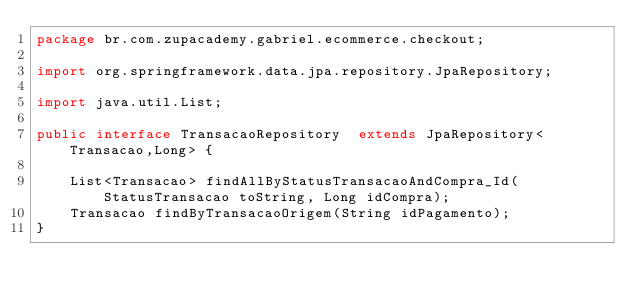<code> <loc_0><loc_0><loc_500><loc_500><_Java_>package br.com.zupacademy.gabriel.ecommerce.checkout;

import org.springframework.data.jpa.repository.JpaRepository;

import java.util.List;

public interface TransacaoRepository  extends JpaRepository<Transacao,Long> {

    List<Transacao> findAllByStatusTransacaoAndCompra_Id(StatusTransacao toString, Long idCompra);
    Transacao findByTransacaoOrigem(String idPagamento);
}</code> 